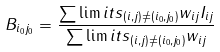Convert formula to latex. <formula><loc_0><loc_0><loc_500><loc_500>B _ { i _ { 0 } j _ { 0 } } = \frac { \sum \lim i t s _ { ( i , j ) \not = ( i _ { 0 } , j _ { 0 } ) } w _ { i j } I _ { i j } } { \sum \lim i t s _ { ( i , j ) \not = ( i _ { 0 } , j _ { 0 } ) } w _ { i j } }</formula> 